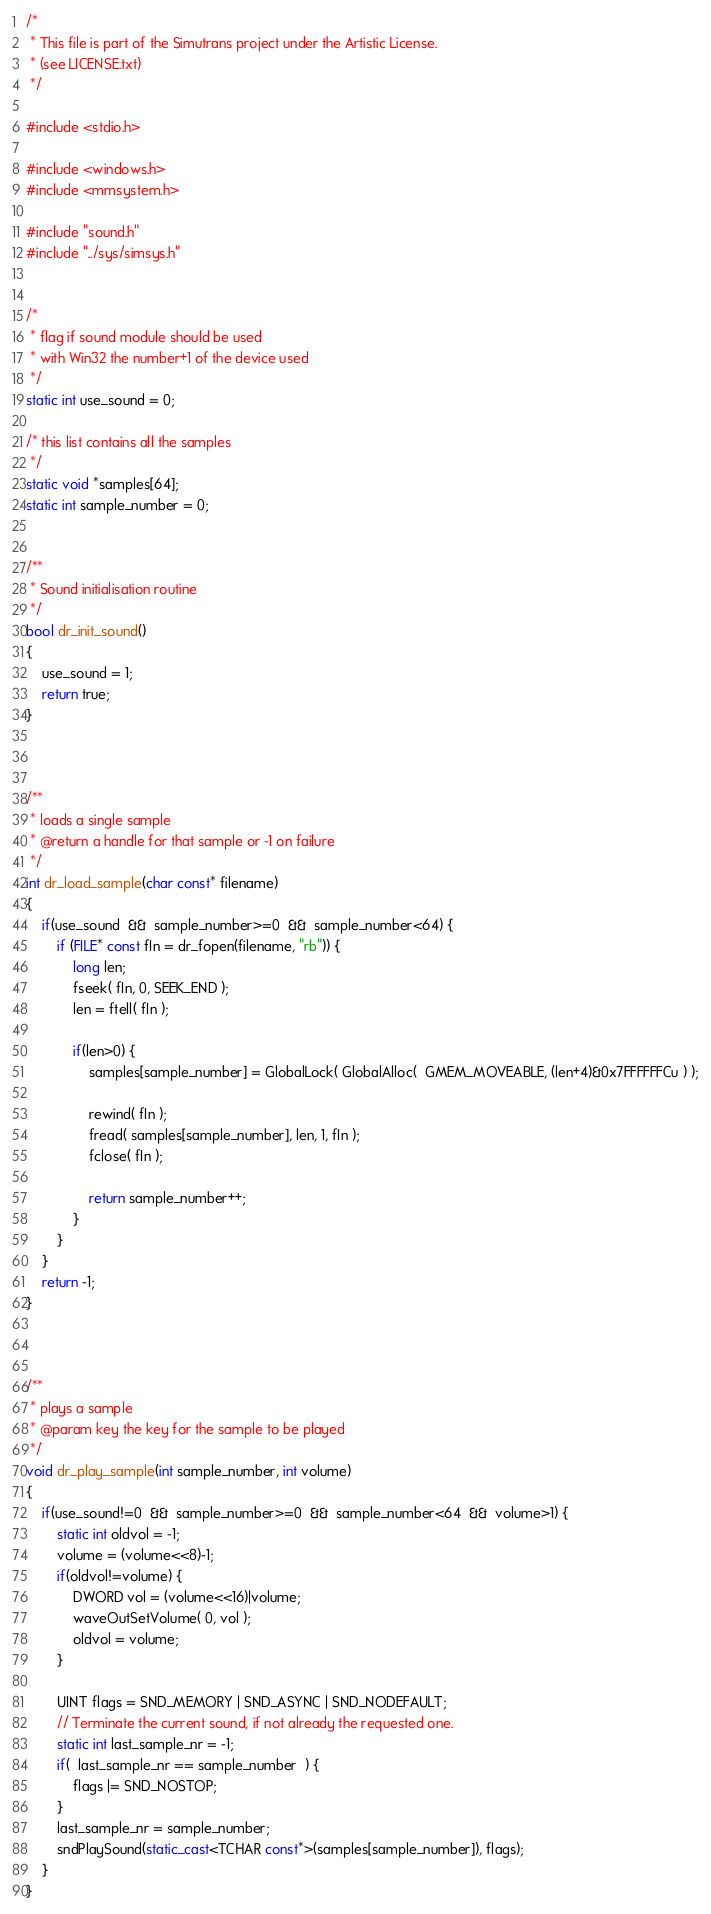<code> <loc_0><loc_0><loc_500><loc_500><_C++_>/*
 * This file is part of the Simutrans project under the Artistic License.
 * (see LICENSE.txt)
 */

#include <stdio.h>

#include <windows.h>
#include <mmsystem.h>

#include "sound.h"
#include "../sys/simsys.h"


/*
 * flag if sound module should be used
 * with Win32 the number+1 of the device used
 */
static int use_sound = 0;

/* this list contains all the samples
 */
static void *samples[64];
static int sample_number = 0;


/**
 * Sound initialisation routine
 */
bool dr_init_sound()
{
	use_sound = 1;
	return true;
}



/**
 * loads a single sample
 * @return a handle for that sample or -1 on failure
 */
int dr_load_sample(char const* filename)
{
	if(use_sound  &&  sample_number>=0  &&  sample_number<64) {
		if (FILE* const fIn = dr_fopen(filename, "rb")) {
			long len;
			fseek( fIn, 0, SEEK_END );
			len = ftell( fIn );

			if(len>0) {
				samples[sample_number] = GlobalLock( GlobalAlloc(  GMEM_MOVEABLE, (len+4)&0x7FFFFFFCu ) );

				rewind( fIn );
				fread( samples[sample_number], len, 1, fIn );
				fclose( fIn );

				return sample_number++;
			}
		}
	}
	return -1;
}



/**
 * plays a sample
 * @param key the key for the sample to be played
 */
void dr_play_sample(int sample_number, int volume)
{
	if(use_sound!=0  &&  sample_number>=0  &&  sample_number<64  &&  volume>1) {
		static int oldvol = -1;
		volume = (volume<<8)-1;
		if(oldvol!=volume) {
			DWORD vol = (volume<<16)|volume;
			waveOutSetVolume( 0, vol );
			oldvol = volume;
		}

		UINT flags = SND_MEMORY | SND_ASYNC | SND_NODEFAULT;
		// Terminate the current sound, if not already the requested one.
		static int last_sample_nr = -1;
		if(  last_sample_nr == sample_number  ) {
			flags |= SND_NOSTOP;
		}
		last_sample_nr = sample_number;
		sndPlaySound(static_cast<TCHAR const*>(samples[sample_number]), flags);
	}
}
</code> 